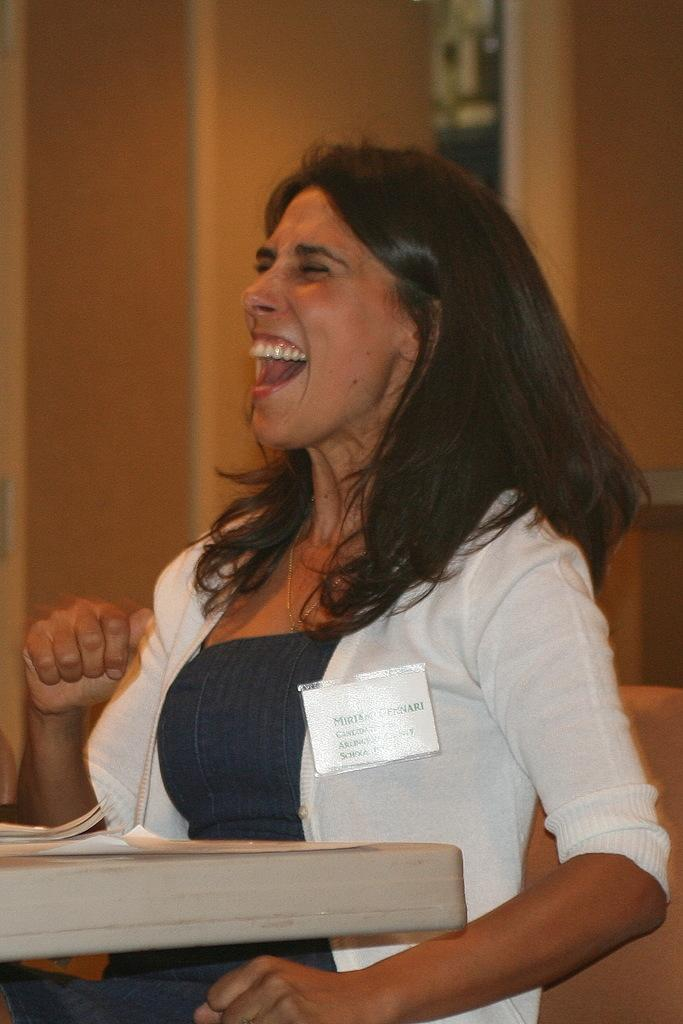Who is the main subject in the foreground of the image? There is a woman in the foreground of the image. What is the woman standing in front of? The woman is in front of a table. What can be seen in the background of the image? There is a wall visible in the background of the image. Where might this image have been taken? The image is likely taken in a room, given the presence of a table and a wall. How many dogs are sitting on the table in the image? There are no dogs present in the image; it features a woman standing in front of a table. 